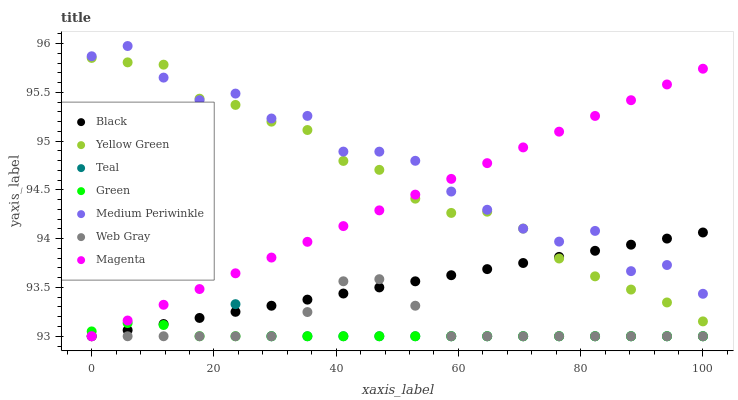Does Green have the minimum area under the curve?
Answer yes or no. Yes. Does Medium Periwinkle have the maximum area under the curve?
Answer yes or no. Yes. Does Yellow Green have the minimum area under the curve?
Answer yes or no. No. Does Yellow Green have the maximum area under the curve?
Answer yes or no. No. Is Black the smoothest?
Answer yes or no. Yes. Is Medium Periwinkle the roughest?
Answer yes or no. Yes. Is Yellow Green the smoothest?
Answer yes or no. No. Is Yellow Green the roughest?
Answer yes or no. No. Does Web Gray have the lowest value?
Answer yes or no. Yes. Does Yellow Green have the lowest value?
Answer yes or no. No. Does Medium Periwinkle have the highest value?
Answer yes or no. Yes. Does Yellow Green have the highest value?
Answer yes or no. No. Is Green less than Yellow Green?
Answer yes or no. Yes. Is Yellow Green greater than Green?
Answer yes or no. Yes. Does Black intersect Green?
Answer yes or no. Yes. Is Black less than Green?
Answer yes or no. No. Is Black greater than Green?
Answer yes or no. No. Does Green intersect Yellow Green?
Answer yes or no. No. 